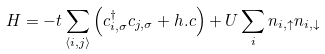Convert formula to latex. <formula><loc_0><loc_0><loc_500><loc_500>H = - t \sum _ { \langle i , j \rangle } \left ( c _ { i , \sigma } ^ { \dag } c _ { j , \sigma } + h . c \right ) + U \sum _ { i } n _ { i , \uparrow } n _ { i , \downarrow }</formula> 